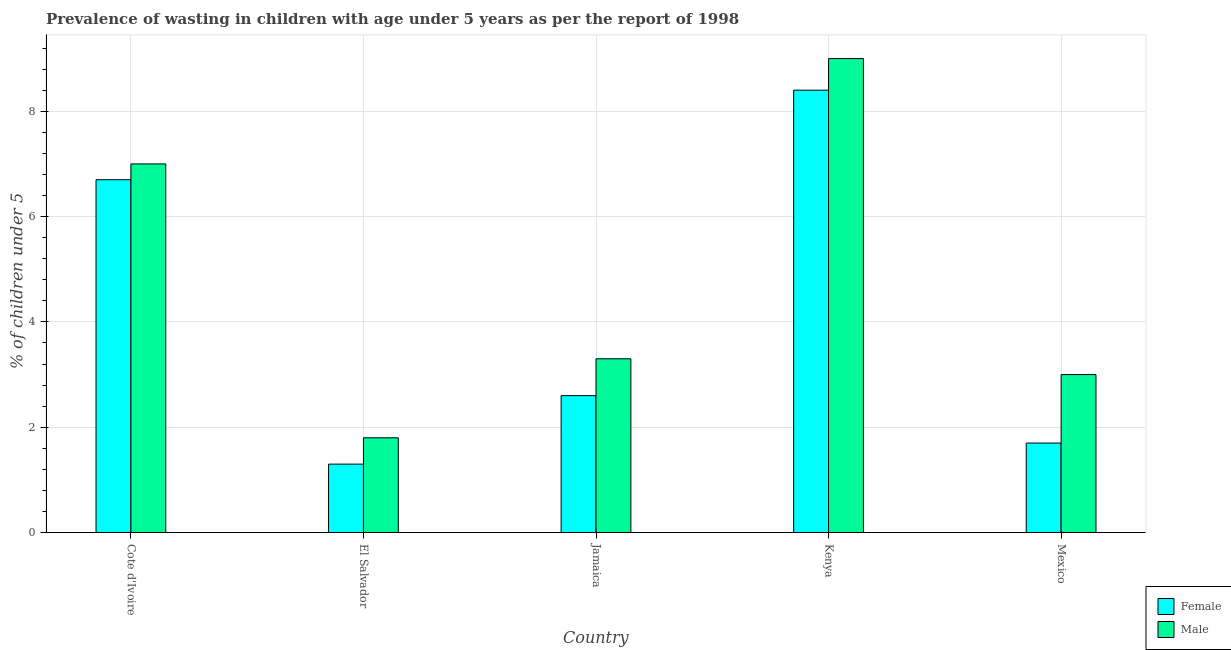How many different coloured bars are there?
Provide a short and direct response. 2. How many bars are there on the 3rd tick from the left?
Your answer should be compact. 2. What is the label of the 3rd group of bars from the left?
Offer a terse response. Jamaica. What is the percentage of undernourished male children in Jamaica?
Your response must be concise. 3.3. Across all countries, what is the maximum percentage of undernourished female children?
Provide a short and direct response. 8.4. Across all countries, what is the minimum percentage of undernourished female children?
Your answer should be compact. 1.3. In which country was the percentage of undernourished female children maximum?
Provide a succinct answer. Kenya. In which country was the percentage of undernourished female children minimum?
Make the answer very short. El Salvador. What is the total percentage of undernourished female children in the graph?
Offer a terse response. 20.7. What is the difference between the percentage of undernourished male children in Cote d'Ivoire and that in Jamaica?
Keep it short and to the point. 3.7. What is the difference between the percentage of undernourished male children in Mexico and the percentage of undernourished female children in Kenya?
Make the answer very short. -5.4. What is the average percentage of undernourished male children per country?
Ensure brevity in your answer.  4.82. What is the difference between the percentage of undernourished male children and percentage of undernourished female children in Jamaica?
Provide a short and direct response. 0.7. In how many countries, is the percentage of undernourished female children greater than 6 %?
Provide a short and direct response. 2. What is the ratio of the percentage of undernourished male children in El Salvador to that in Mexico?
Keep it short and to the point. 0.6. What is the difference between the highest and the second highest percentage of undernourished female children?
Your response must be concise. 1.7. What is the difference between the highest and the lowest percentage of undernourished male children?
Your answer should be compact. 7.2. In how many countries, is the percentage of undernourished female children greater than the average percentage of undernourished female children taken over all countries?
Make the answer very short. 2. Is the sum of the percentage of undernourished female children in El Salvador and Kenya greater than the maximum percentage of undernourished male children across all countries?
Offer a terse response. Yes. What does the 1st bar from the left in Kenya represents?
Your response must be concise. Female. How many bars are there?
Keep it short and to the point. 10. How many countries are there in the graph?
Offer a very short reply. 5. What is the difference between two consecutive major ticks on the Y-axis?
Provide a short and direct response. 2. Are the values on the major ticks of Y-axis written in scientific E-notation?
Provide a short and direct response. No. How are the legend labels stacked?
Your answer should be compact. Vertical. What is the title of the graph?
Offer a terse response. Prevalence of wasting in children with age under 5 years as per the report of 1998. What is the label or title of the Y-axis?
Your response must be concise.  % of children under 5. What is the  % of children under 5 in Female in Cote d'Ivoire?
Provide a short and direct response. 6.7. What is the  % of children under 5 of Male in Cote d'Ivoire?
Ensure brevity in your answer.  7. What is the  % of children under 5 in Female in El Salvador?
Give a very brief answer. 1.3. What is the  % of children under 5 of Male in El Salvador?
Provide a succinct answer. 1.8. What is the  % of children under 5 of Female in Jamaica?
Keep it short and to the point. 2.6. What is the  % of children under 5 of Male in Jamaica?
Your response must be concise. 3.3. What is the  % of children under 5 in Female in Kenya?
Give a very brief answer. 8.4. What is the  % of children under 5 of Female in Mexico?
Provide a succinct answer. 1.7. Across all countries, what is the maximum  % of children under 5 of Female?
Provide a short and direct response. 8.4. Across all countries, what is the minimum  % of children under 5 in Female?
Keep it short and to the point. 1.3. Across all countries, what is the minimum  % of children under 5 in Male?
Ensure brevity in your answer.  1.8. What is the total  % of children under 5 of Female in the graph?
Keep it short and to the point. 20.7. What is the total  % of children under 5 of Male in the graph?
Offer a very short reply. 24.1. What is the difference between the  % of children under 5 in Male in Cote d'Ivoire and that in El Salvador?
Provide a short and direct response. 5.2. What is the difference between the  % of children under 5 in Female in Cote d'Ivoire and that in Kenya?
Offer a terse response. -1.7. What is the difference between the  % of children under 5 in Male in Cote d'Ivoire and that in Kenya?
Provide a short and direct response. -2. What is the difference between the  % of children under 5 in Female in Cote d'Ivoire and that in Mexico?
Ensure brevity in your answer.  5. What is the difference between the  % of children under 5 of Male in Cote d'Ivoire and that in Mexico?
Your response must be concise. 4. What is the difference between the  % of children under 5 of Female in El Salvador and that in Jamaica?
Your answer should be compact. -1.3. What is the difference between the  % of children under 5 in Female in El Salvador and that in Kenya?
Keep it short and to the point. -7.1. What is the difference between the  % of children under 5 of Male in El Salvador and that in Kenya?
Provide a succinct answer. -7.2. What is the difference between the  % of children under 5 of Male in Jamaica and that in Mexico?
Give a very brief answer. 0.3. What is the difference between the  % of children under 5 in Female in Cote d'Ivoire and the  % of children under 5 in Male in Kenya?
Offer a terse response. -2.3. What is the difference between the  % of children under 5 in Female in Cote d'Ivoire and the  % of children under 5 in Male in Mexico?
Keep it short and to the point. 3.7. What is the difference between the  % of children under 5 in Female in El Salvador and the  % of children under 5 in Male in Mexico?
Your answer should be compact. -1.7. What is the average  % of children under 5 of Female per country?
Give a very brief answer. 4.14. What is the average  % of children under 5 of Male per country?
Give a very brief answer. 4.82. What is the difference between the  % of children under 5 in Female and  % of children under 5 in Male in Jamaica?
Offer a terse response. -0.7. What is the difference between the  % of children under 5 in Female and  % of children under 5 in Male in Mexico?
Ensure brevity in your answer.  -1.3. What is the ratio of the  % of children under 5 in Female in Cote d'Ivoire to that in El Salvador?
Keep it short and to the point. 5.15. What is the ratio of the  % of children under 5 of Male in Cote d'Ivoire to that in El Salvador?
Give a very brief answer. 3.89. What is the ratio of the  % of children under 5 in Female in Cote d'Ivoire to that in Jamaica?
Make the answer very short. 2.58. What is the ratio of the  % of children under 5 in Male in Cote d'Ivoire to that in Jamaica?
Ensure brevity in your answer.  2.12. What is the ratio of the  % of children under 5 in Female in Cote d'Ivoire to that in Kenya?
Ensure brevity in your answer.  0.8. What is the ratio of the  % of children under 5 of Male in Cote d'Ivoire to that in Kenya?
Provide a short and direct response. 0.78. What is the ratio of the  % of children under 5 of Female in Cote d'Ivoire to that in Mexico?
Provide a short and direct response. 3.94. What is the ratio of the  % of children under 5 in Male in Cote d'Ivoire to that in Mexico?
Offer a terse response. 2.33. What is the ratio of the  % of children under 5 in Male in El Salvador to that in Jamaica?
Ensure brevity in your answer.  0.55. What is the ratio of the  % of children under 5 in Female in El Salvador to that in Kenya?
Give a very brief answer. 0.15. What is the ratio of the  % of children under 5 of Male in El Salvador to that in Kenya?
Keep it short and to the point. 0.2. What is the ratio of the  % of children under 5 of Female in El Salvador to that in Mexico?
Make the answer very short. 0.76. What is the ratio of the  % of children under 5 of Male in El Salvador to that in Mexico?
Your answer should be compact. 0.6. What is the ratio of the  % of children under 5 of Female in Jamaica to that in Kenya?
Offer a terse response. 0.31. What is the ratio of the  % of children under 5 of Male in Jamaica to that in Kenya?
Make the answer very short. 0.37. What is the ratio of the  % of children under 5 of Female in Jamaica to that in Mexico?
Provide a short and direct response. 1.53. What is the ratio of the  % of children under 5 in Male in Jamaica to that in Mexico?
Offer a very short reply. 1.1. What is the ratio of the  % of children under 5 of Female in Kenya to that in Mexico?
Make the answer very short. 4.94. What is the difference between the highest and the second highest  % of children under 5 of Female?
Make the answer very short. 1.7. What is the difference between the highest and the lowest  % of children under 5 in Female?
Your answer should be compact. 7.1. 